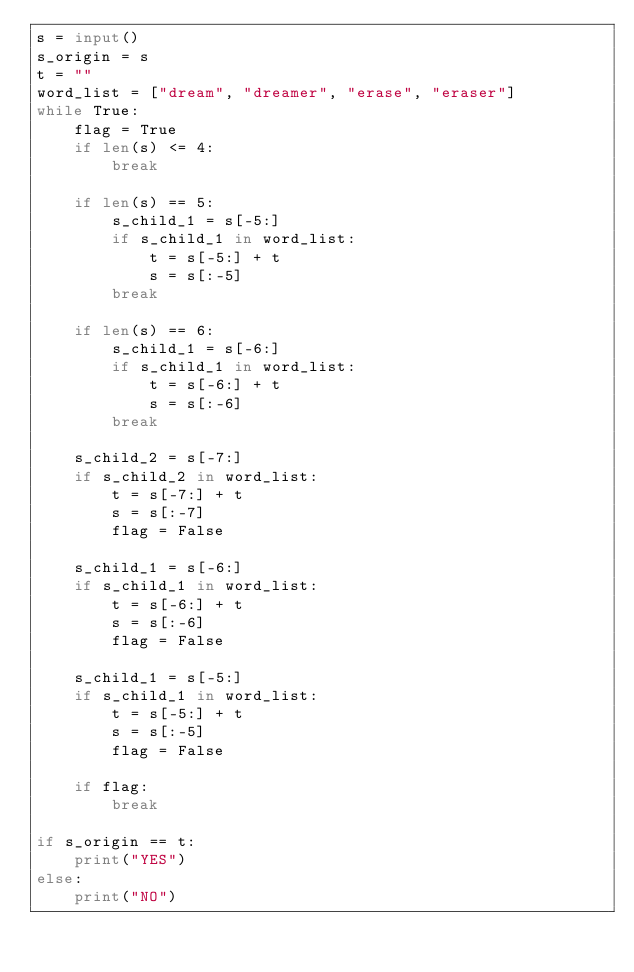Convert code to text. <code><loc_0><loc_0><loc_500><loc_500><_Python_>s = input()
s_origin = s
t = ""
word_list = ["dream", "dreamer", "erase", "eraser"]
while True:
    flag = True
    if len(s) <= 4:
        break

    if len(s) == 5:
        s_child_1 = s[-5:]
        if s_child_1 in word_list:
            t = s[-5:] + t
            s = s[:-5]
        break
    
    if len(s) == 6:
        s_child_1 = s[-6:]
        if s_child_1 in word_list:
            t = s[-6:] + t
            s = s[:-6]
        break

    s_child_2 = s[-7:]
    if s_child_2 in word_list:
        t = s[-7:] + t
        s = s[:-7]
        flag = False

    s_child_1 = s[-6:]
    if s_child_1 in word_list:
        t = s[-6:] + t
        s = s[:-6]
        flag = False

    s_child_1 = s[-5:]
    if s_child_1 in word_list:
        t = s[-5:] + t
        s = s[:-5]
        flag = False
    
    if flag:
        break

if s_origin == t:
    print("YES")
else:
    print("NO")
    </code> 